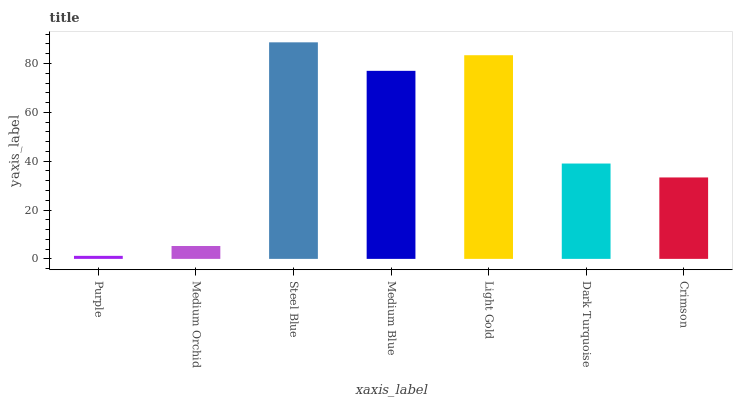Is Purple the minimum?
Answer yes or no. Yes. Is Steel Blue the maximum?
Answer yes or no. Yes. Is Medium Orchid the minimum?
Answer yes or no. No. Is Medium Orchid the maximum?
Answer yes or no. No. Is Medium Orchid greater than Purple?
Answer yes or no. Yes. Is Purple less than Medium Orchid?
Answer yes or no. Yes. Is Purple greater than Medium Orchid?
Answer yes or no. No. Is Medium Orchid less than Purple?
Answer yes or no. No. Is Dark Turquoise the high median?
Answer yes or no. Yes. Is Dark Turquoise the low median?
Answer yes or no. Yes. Is Medium Blue the high median?
Answer yes or no. No. Is Steel Blue the low median?
Answer yes or no. No. 